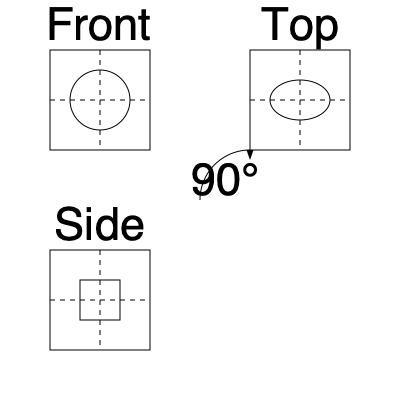An engine component is shown in three views: front, top, and side. If the component is rotated 90° clockwise when viewed from above, which view will now appear identical to the original front view? To solve this problem, we need to visualize the rotation of the 3D engine component:

1. Analyze the given views:
   - Front view: Shows a circle within a square
   - Top view: Shows an ellipse within a square
   - Side view: Shows a smaller square within a larger square

2. Understand the rotation:
   - The component is rotated 90° clockwise when viewed from above
   - This means the front face will move to where the right side was

3. Visualize the rotation:
   - The circular face (originally in front) will now face the right side
   - The rectangular face (originally on the side) will now face the front

4. Compare the rotated position to the original views:
   - The new front view will match the original side view
   - The new side view will match the original front view
   - The top view remains unchanged

5. Conclude:
   - After rotation, the original side view will appear identical to the new front view

Therefore, the view that will appear identical to the original front view after rotation is the side view.
Answer: Side view 